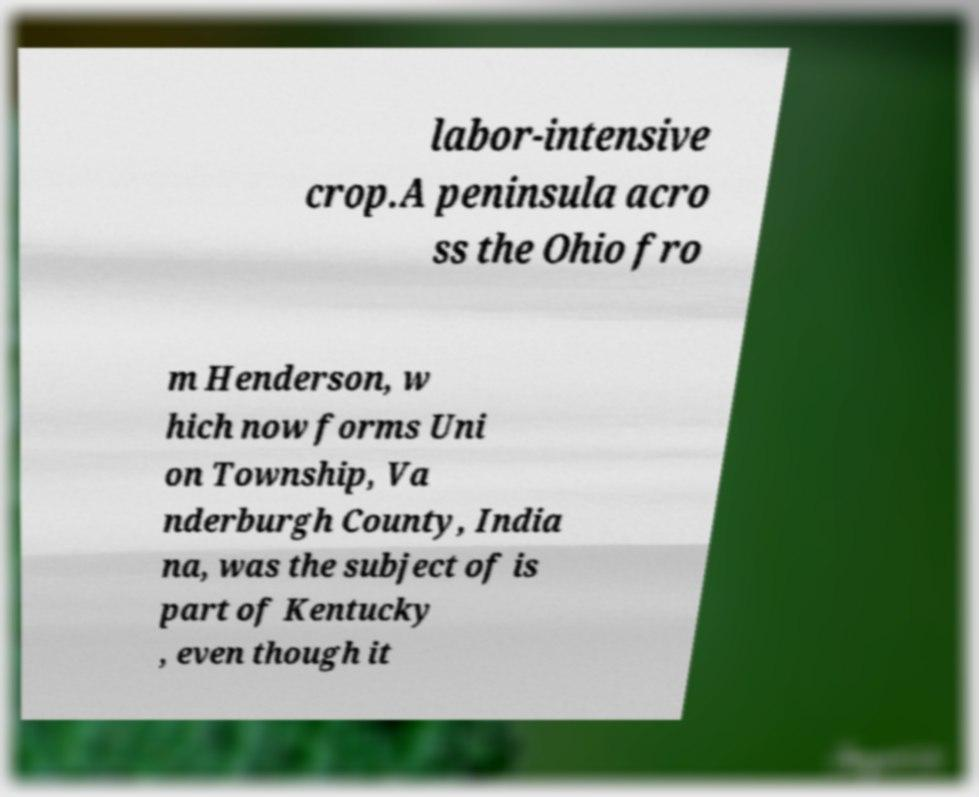Could you assist in decoding the text presented in this image and type it out clearly? labor-intensive crop.A peninsula acro ss the Ohio fro m Henderson, w hich now forms Uni on Township, Va nderburgh County, India na, was the subject of is part of Kentucky , even though it 